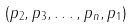Convert formula to latex. <formula><loc_0><loc_0><loc_500><loc_500>( p _ { 2 } , p _ { 3 } , \dots , p _ { n } , p _ { 1 } )</formula> 